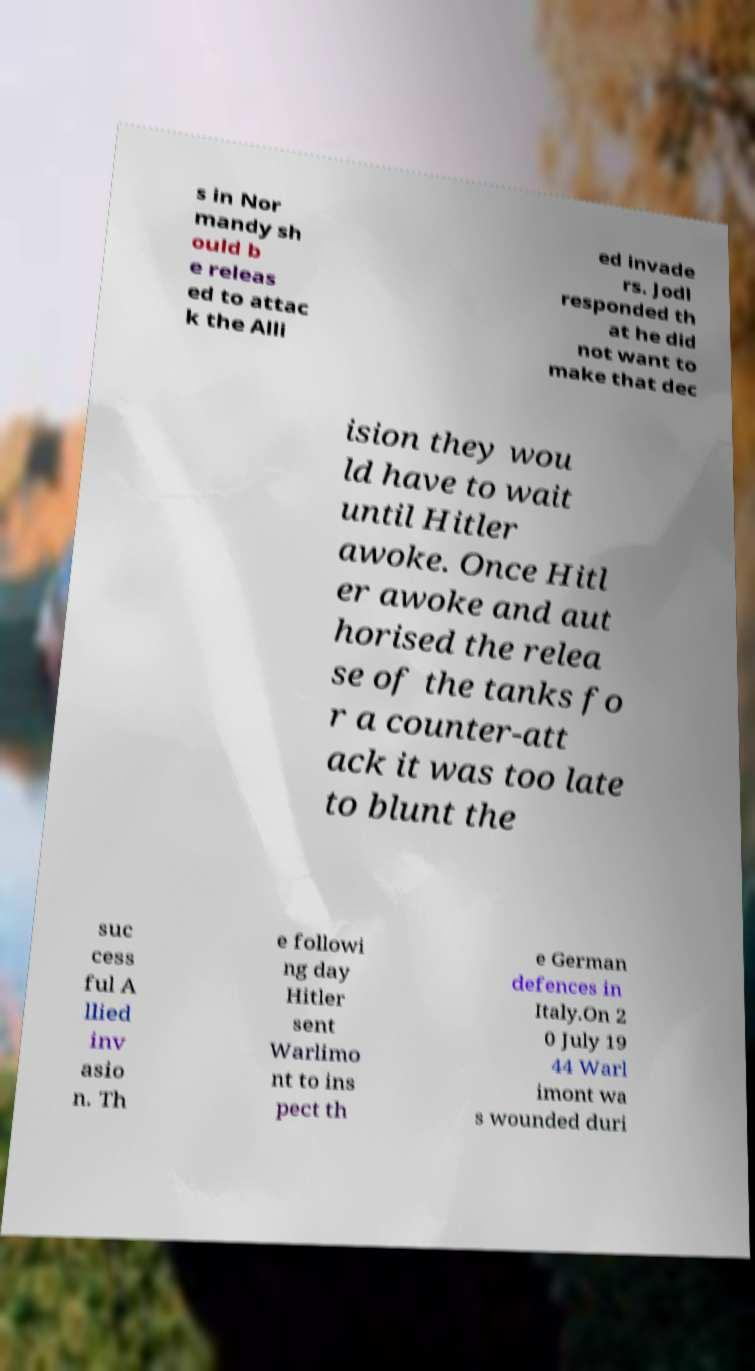Could you extract and type out the text from this image? s in Nor mandy sh ould b e releas ed to attac k the Alli ed invade rs. Jodl responded th at he did not want to make that dec ision they wou ld have to wait until Hitler awoke. Once Hitl er awoke and aut horised the relea se of the tanks fo r a counter-att ack it was too late to blunt the suc cess ful A llied inv asio n. Th e followi ng day Hitler sent Warlimo nt to ins pect th e German defences in Italy.On 2 0 July 19 44 Warl imont wa s wounded duri 